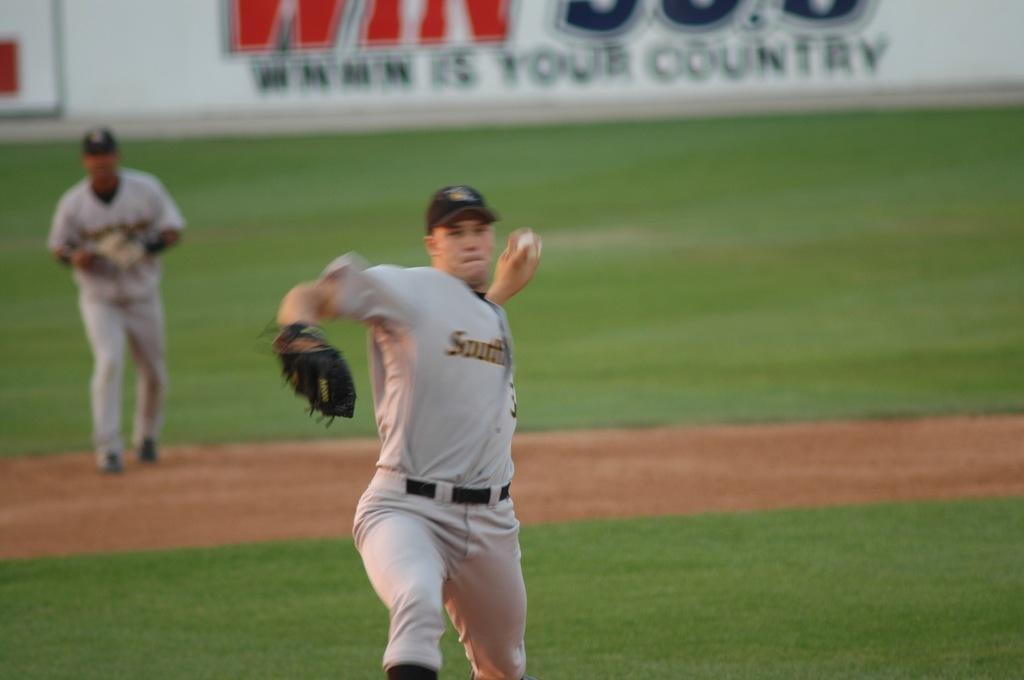Which direction is on the jersey?
Provide a succinct answer. South. What kind of music does the radio station advertised play?
Your answer should be compact. Country. 